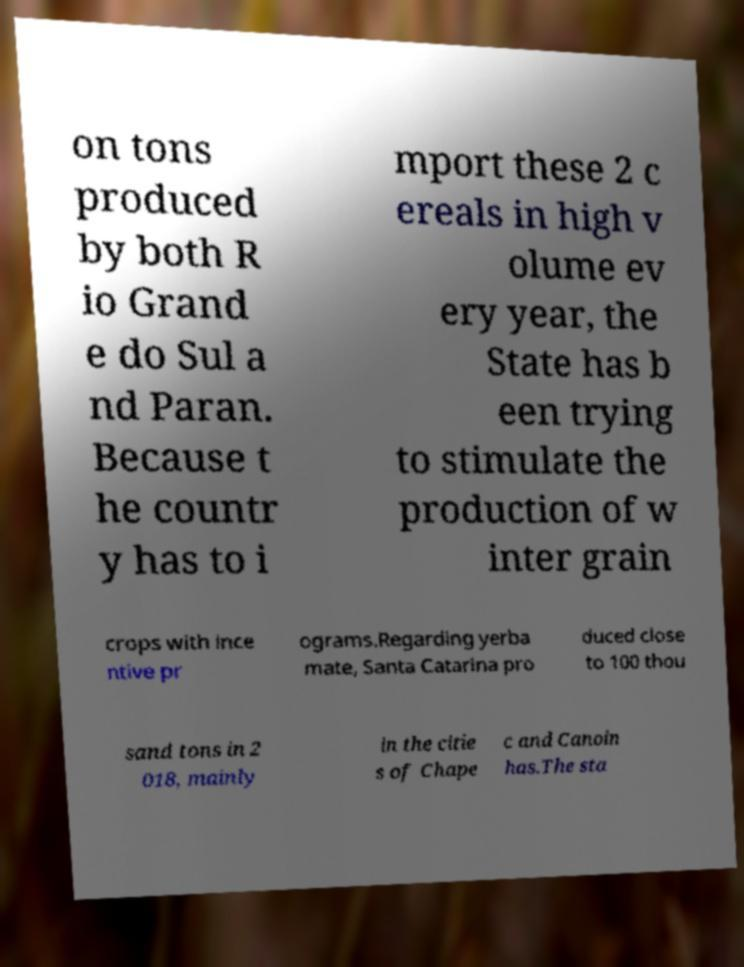For documentation purposes, I need the text within this image transcribed. Could you provide that? on tons produced by both R io Grand e do Sul a nd Paran. Because t he countr y has to i mport these 2 c ereals in high v olume ev ery year, the State has b een trying to stimulate the production of w inter grain crops with ince ntive pr ograms.Regarding yerba mate, Santa Catarina pro duced close to 100 thou sand tons in 2 018, mainly in the citie s of Chape c and Canoin has.The sta 